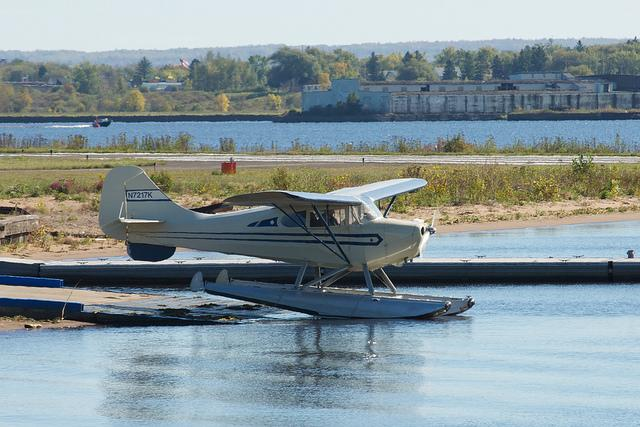What class of aircraft is seen here? Please explain your reasoning. amphibious. The aircraft does not have rotors. it has a civilian tail number and is too small to be a cargo plane. 